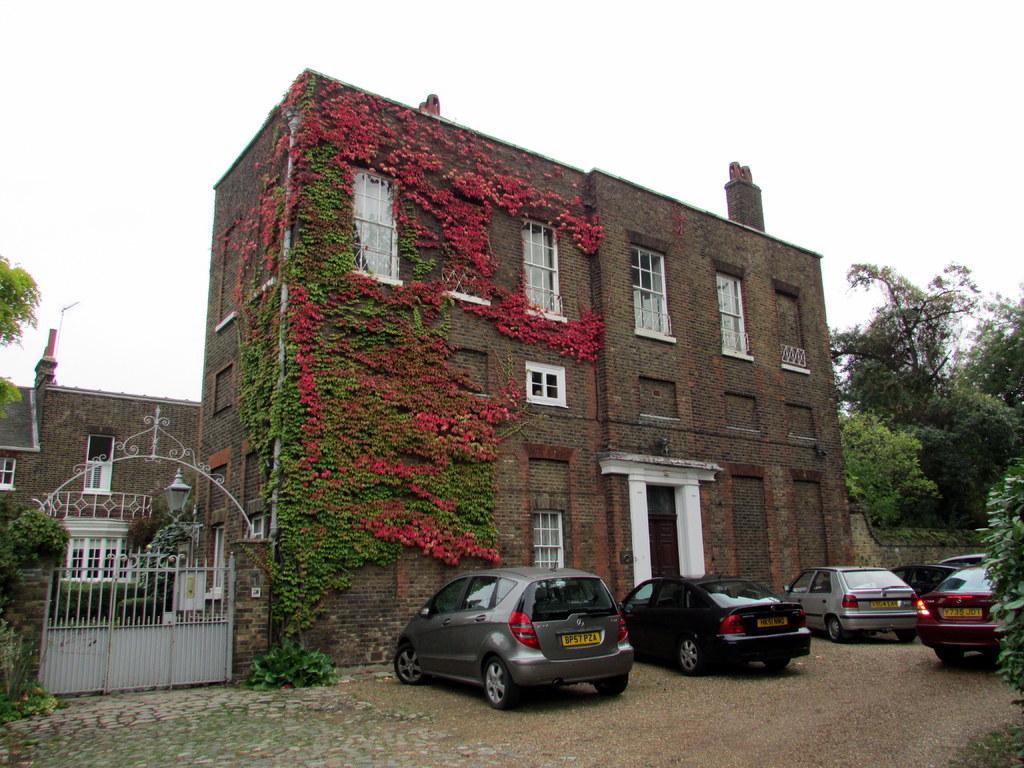Describe this image in one or two sentences. In this picture we can see a building, there are cars in the front, on the left side there is a gate, we can see trees on the right side and left side, there is the sky at the top of the picture, we can see windows of this building, we can also see a light on the left side, at the bottom there is a plant. 